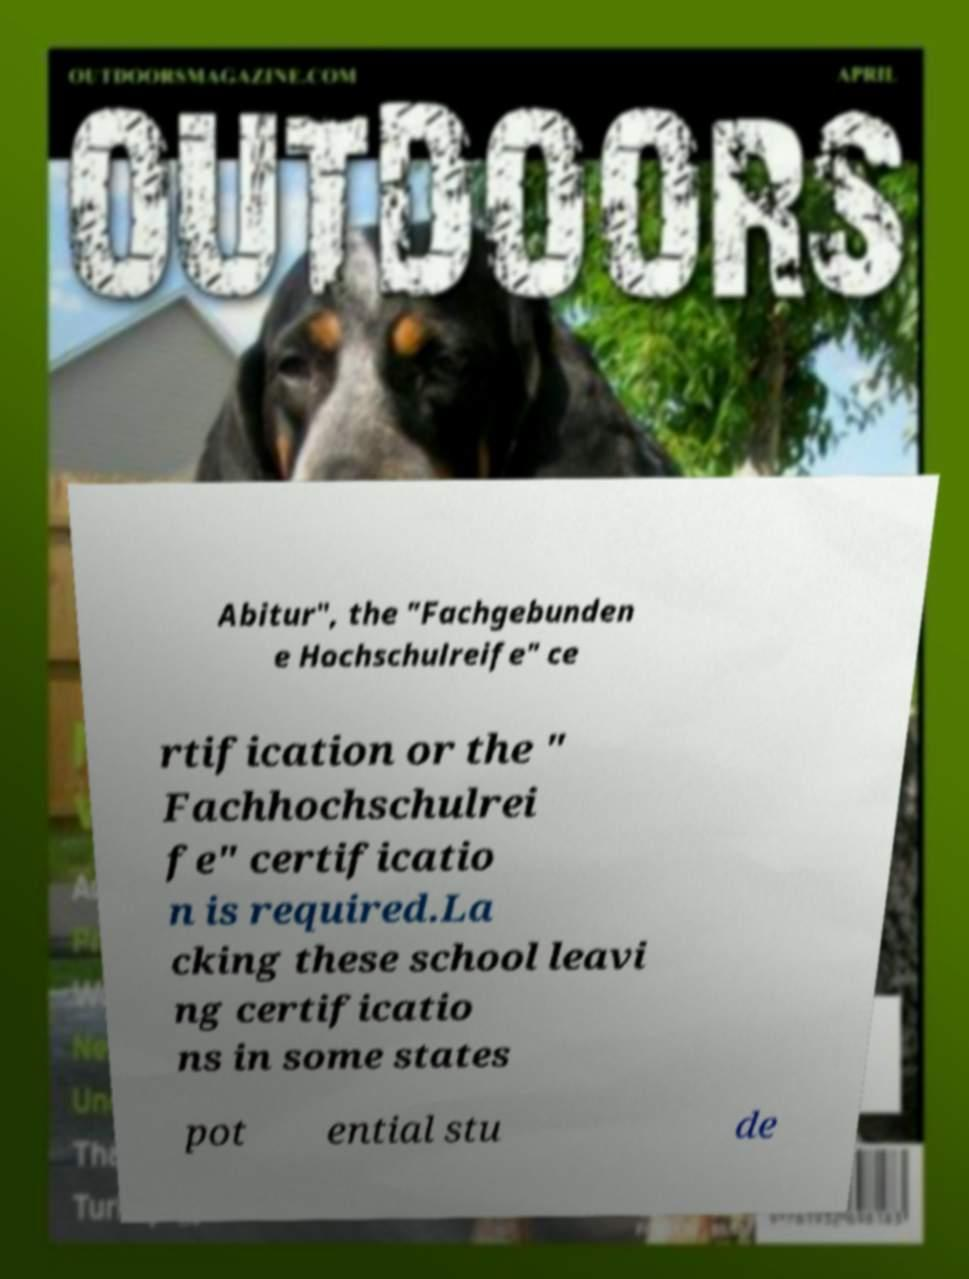Can you read and provide the text displayed in the image?This photo seems to have some interesting text. Can you extract and type it out for me? Abitur", the "Fachgebunden e Hochschulreife" ce rtification or the " Fachhochschulrei fe" certificatio n is required.La cking these school leavi ng certificatio ns in some states pot ential stu de 